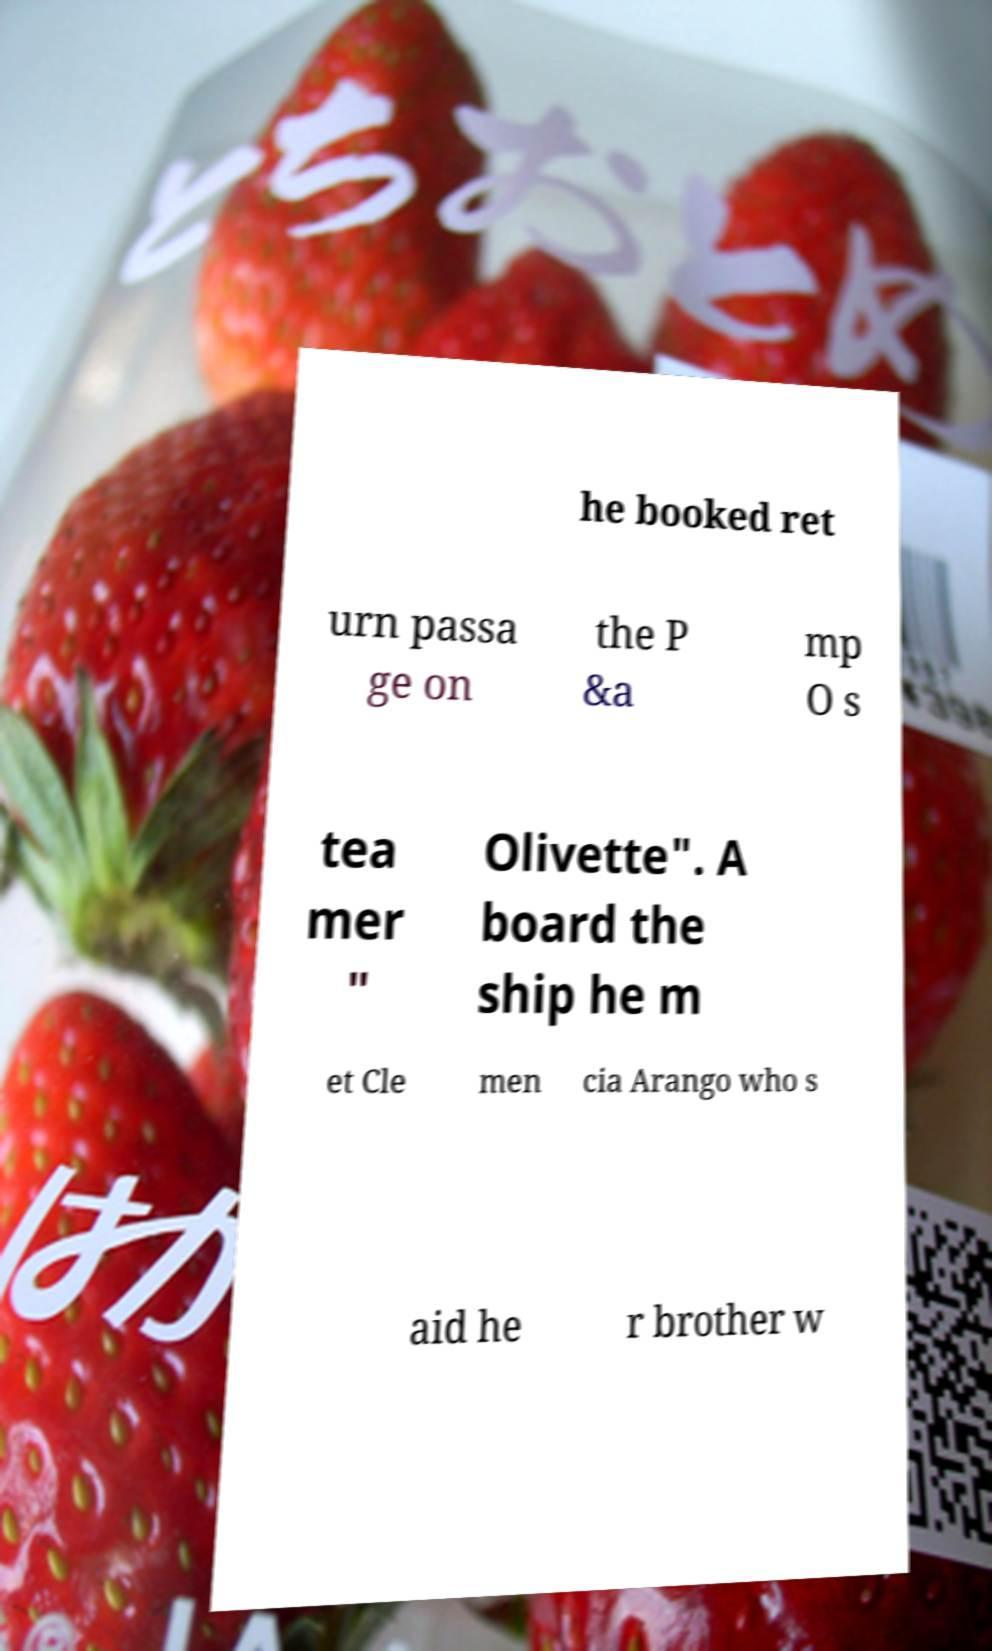What messages or text are displayed in this image? I need them in a readable, typed format. he booked ret urn passa ge on the P &a mp O s tea mer " Olivette". A board the ship he m et Cle men cia Arango who s aid he r brother w 